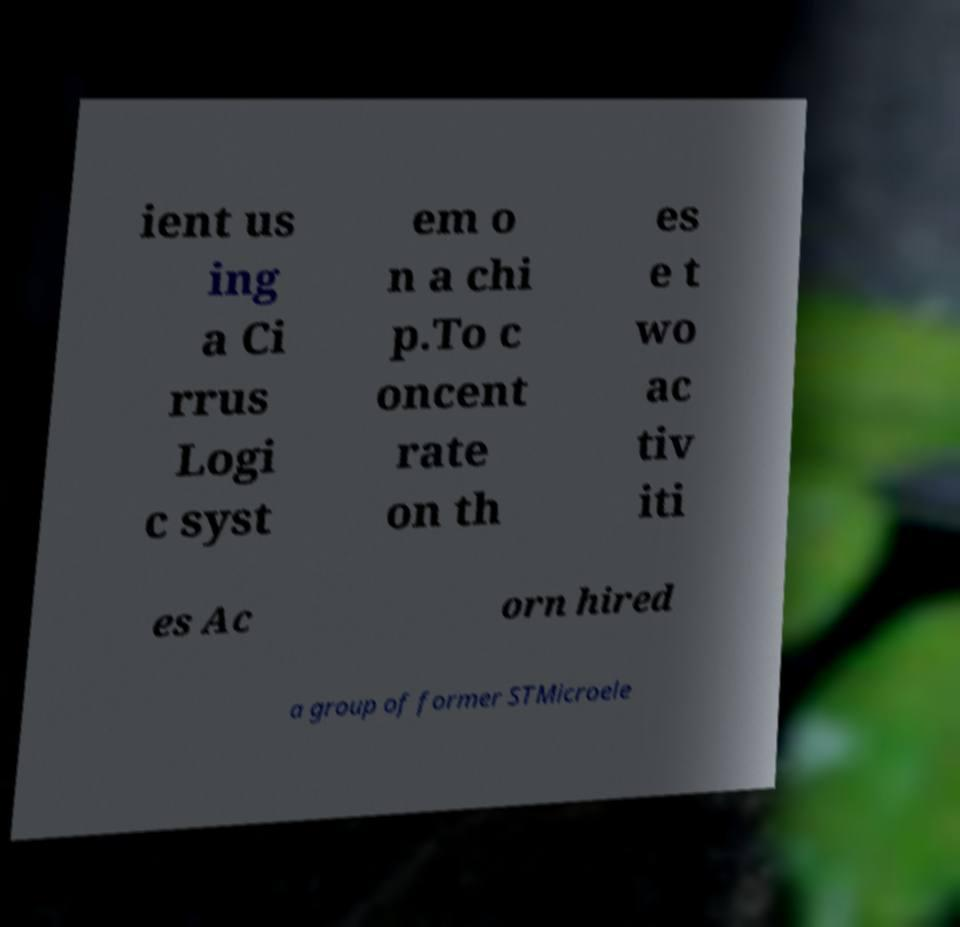Could you assist in decoding the text presented in this image and type it out clearly? ient us ing a Ci rrus Logi c syst em o n a chi p.To c oncent rate on th es e t wo ac tiv iti es Ac orn hired a group of former STMicroele 